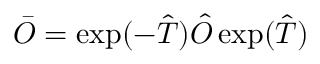<formula> <loc_0><loc_0><loc_500><loc_500>\bar { O } = \exp ( - \hat { T } ) \hat { O } \exp ( \hat { T } )</formula> 